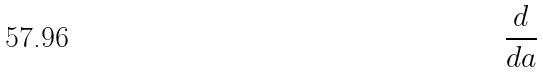<formula> <loc_0><loc_0><loc_500><loc_500>\frac { d } { d a }</formula> 